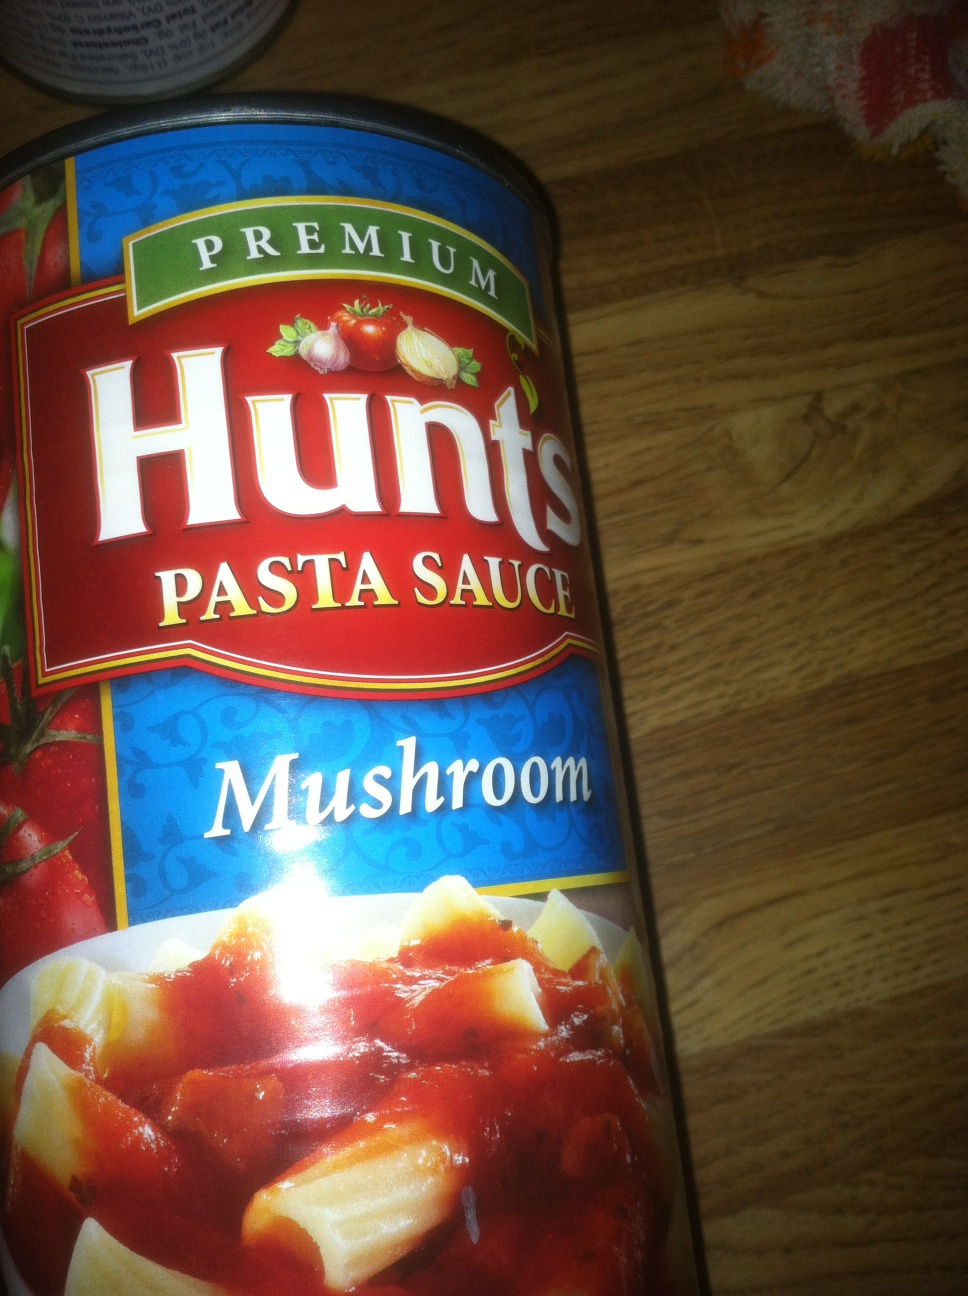Can you tell me how this sauce might be used in cooking? This mushroom-flavored pasta sauce is versatile and can be used in numerous dishes. It's perfect for enhancing pasta recipes, such as spaghetti or penne. You can also use it as a base for a creamy tomato soup or as a sauce for a meatball sub. 